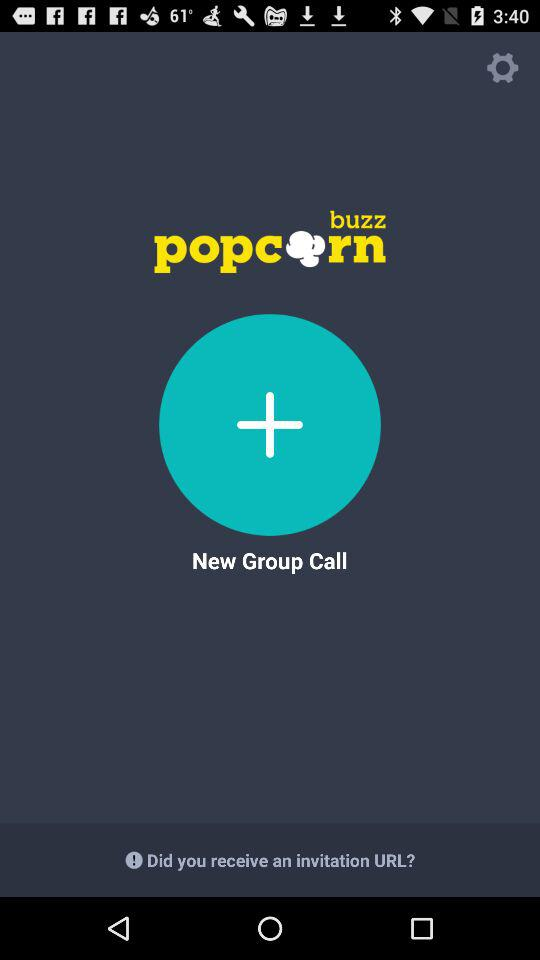What is the application name? The application name is "buzz popcorn". 